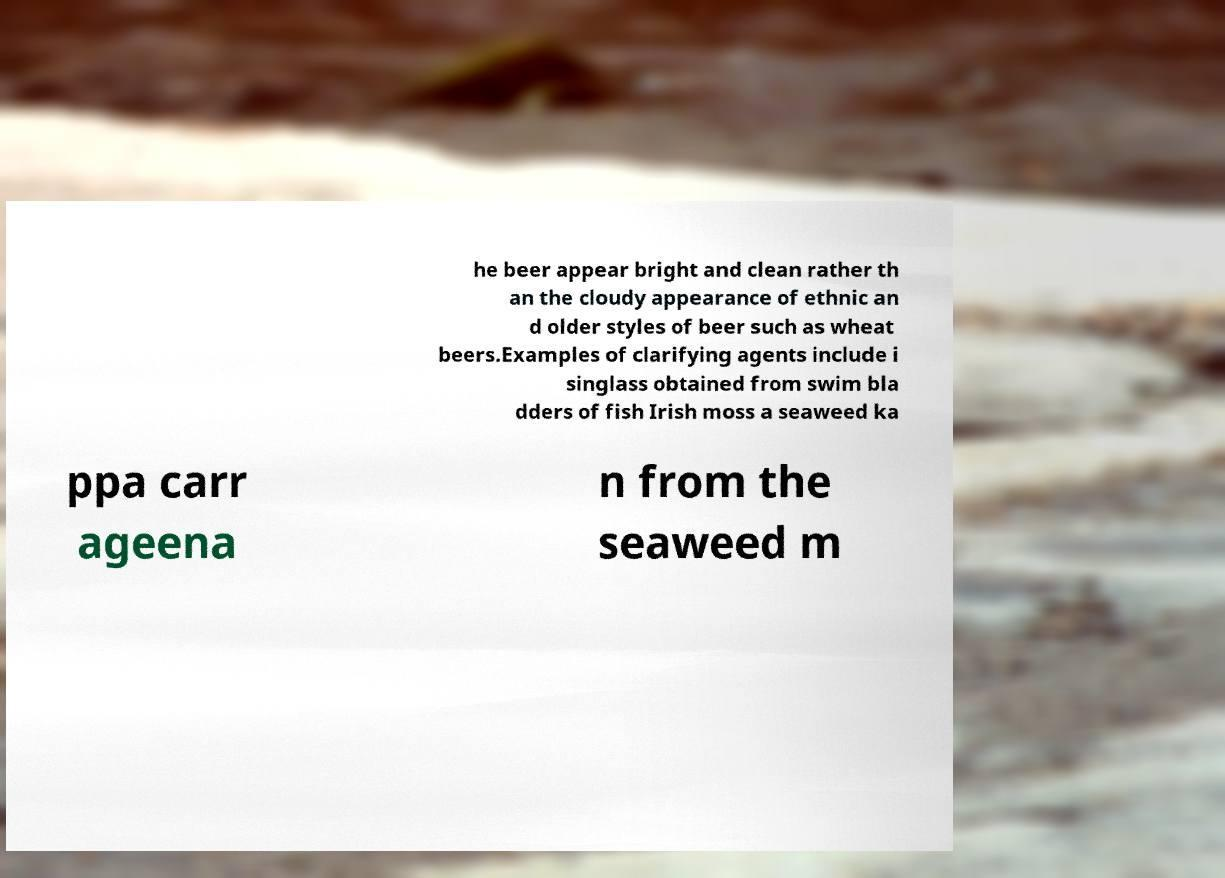For documentation purposes, I need the text within this image transcribed. Could you provide that? he beer appear bright and clean rather th an the cloudy appearance of ethnic an d older styles of beer such as wheat beers.Examples of clarifying agents include i singlass obtained from swim bla dders of fish Irish moss a seaweed ka ppa carr ageena n from the seaweed m 